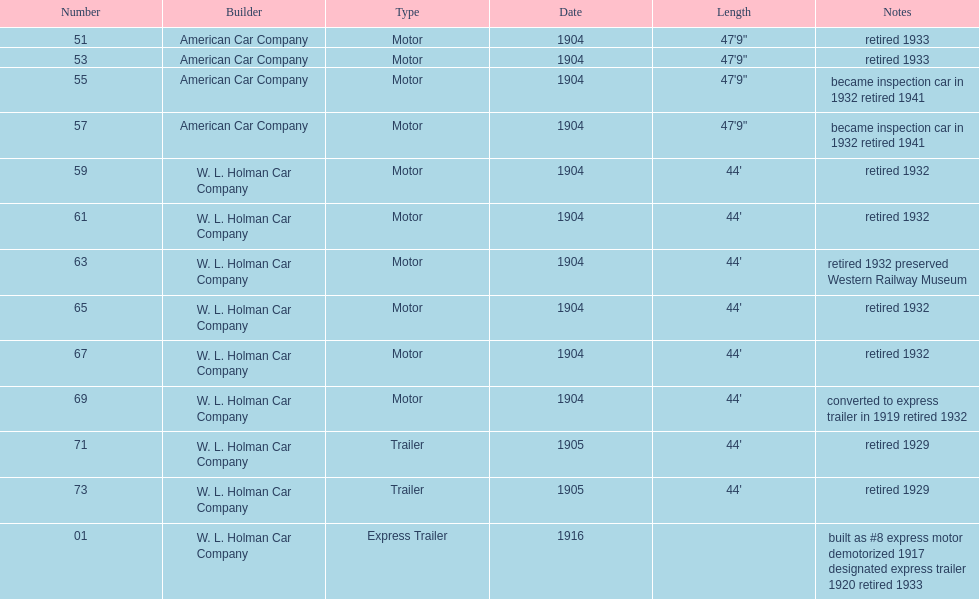How many years did number 71 work before retiring? 24. 